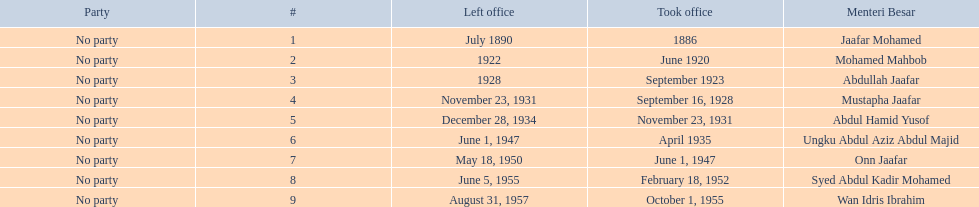Which menteri besars took office in the 1920's? Mohamed Mahbob, Abdullah Jaafar, Mustapha Jaafar. Of those men, who was only in office for 2 years? Mohamed Mahbob. 